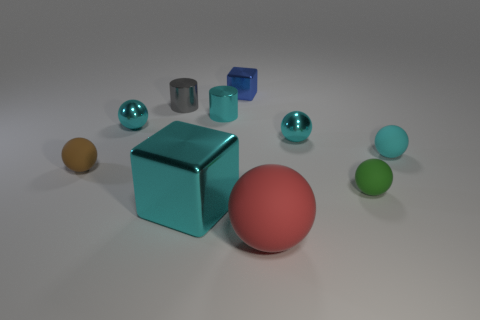What number of objects are both in front of the blue cube and behind the large matte ball?
Your answer should be compact. 8. Is the number of small cyan metal spheres the same as the number of tiny green rubber blocks?
Provide a succinct answer. No. What is the shape of the small matte object that is the same color as the big cube?
Your response must be concise. Sphere. There is a thing that is on the left side of the red thing and in front of the green matte thing; what is it made of?
Your response must be concise. Metal. Is the number of cyan blocks that are in front of the cyan block less than the number of red things behind the small gray cylinder?
Make the answer very short. No. There is a green object that is made of the same material as the brown ball; what is its size?
Your answer should be very brief. Small. Is there any other thing that has the same color as the large block?
Make the answer very short. Yes. Do the green ball and the cyan object in front of the brown matte ball have the same material?
Your answer should be very brief. No. What is the material of the brown object that is the same shape as the cyan matte thing?
Make the answer very short. Rubber. Is there any other thing that is made of the same material as the small gray object?
Keep it short and to the point. Yes. 